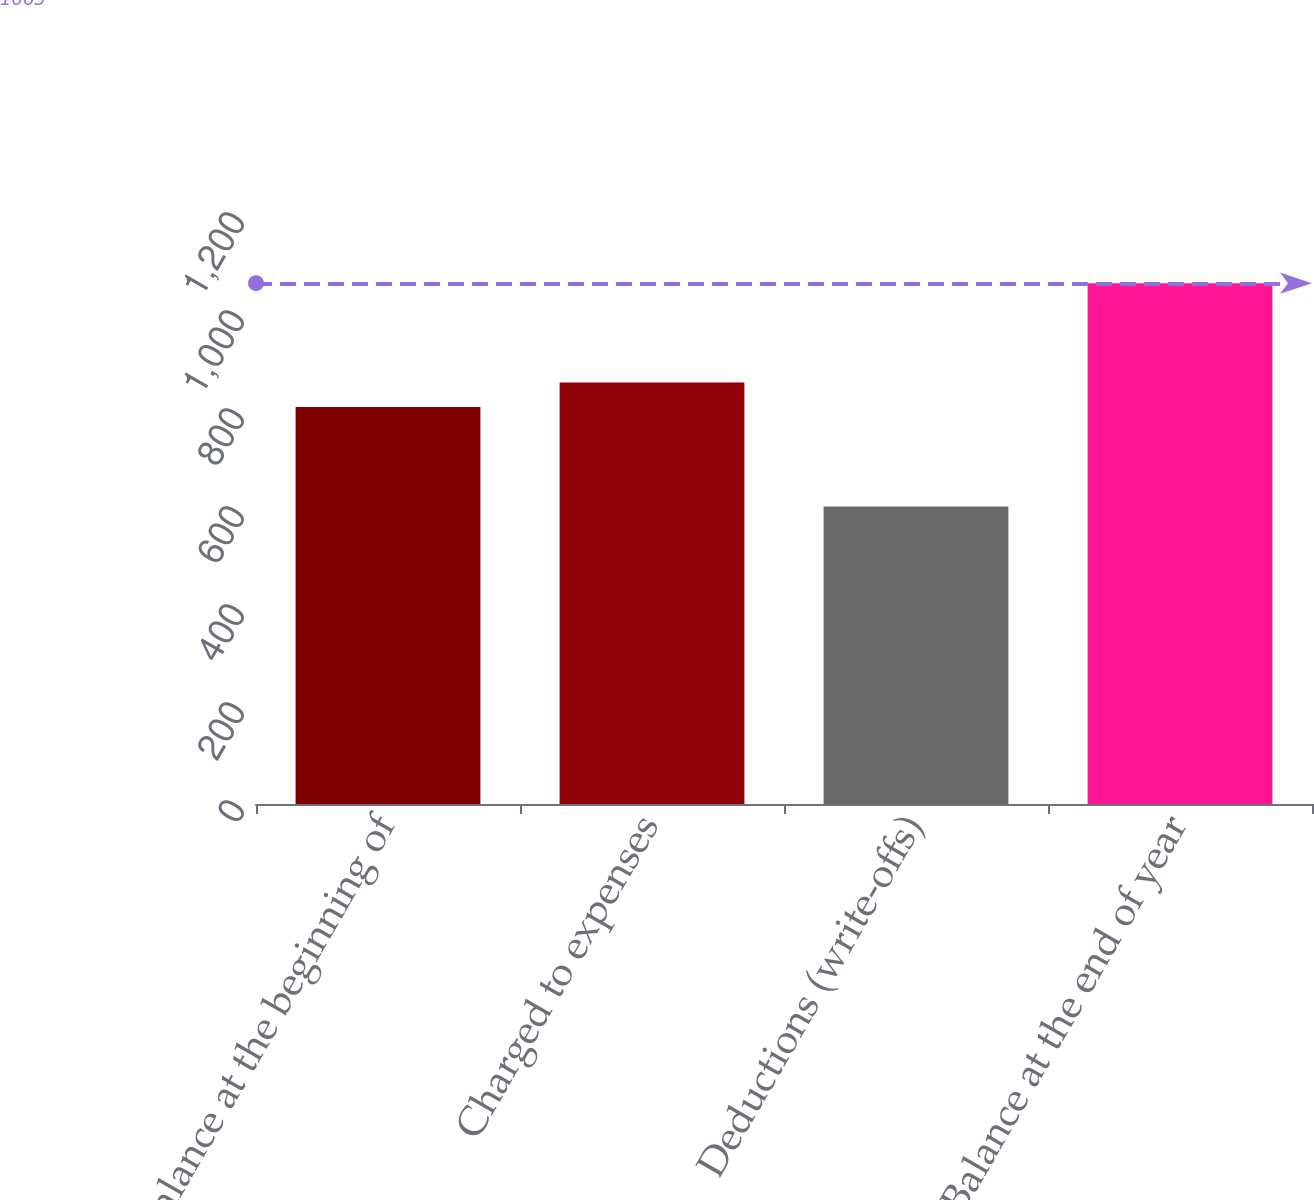Convert chart to OTSL. <chart><loc_0><loc_0><loc_500><loc_500><bar_chart><fcel>Balance at the beginning of<fcel>Charged to expenses<fcel>Deductions (write-offs)<fcel>Balance at the end of year<nl><fcel>810<fcel>860<fcel>607<fcel>1063<nl></chart> 